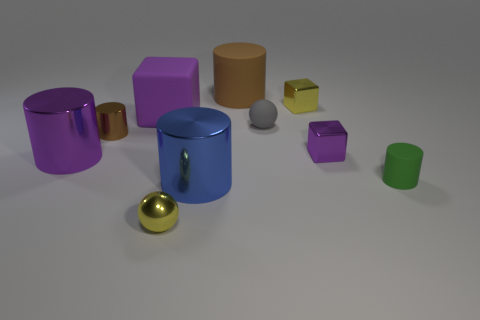What number of things are tiny yellow metallic objects behind the green object or cylinders that are to the right of the tiny yellow sphere?
Ensure brevity in your answer.  4. What color is the matte object that is in front of the big brown matte cylinder and on the left side of the gray ball?
Your response must be concise. Purple. Is the number of tiny brown things greater than the number of shiny cylinders?
Offer a very short reply. No. There is a big object behind the yellow metallic cube; is its shape the same as the tiny brown thing?
Your answer should be very brief. Yes. What number of shiny things are either purple things or gray spheres?
Provide a succinct answer. 2. Are there any gray spheres made of the same material as the large purple cube?
Your response must be concise. Yes. What is the material of the blue cylinder?
Provide a succinct answer. Metal. There is a small yellow thing in front of the purple object to the right of the small yellow metallic object that is to the right of the big brown cylinder; what shape is it?
Provide a succinct answer. Sphere. Are there more purple metal cubes that are behind the tiny brown object than big purple cubes?
Provide a succinct answer. No. Is the shape of the tiny purple object the same as the shiny object in front of the blue shiny cylinder?
Your answer should be compact. No. 